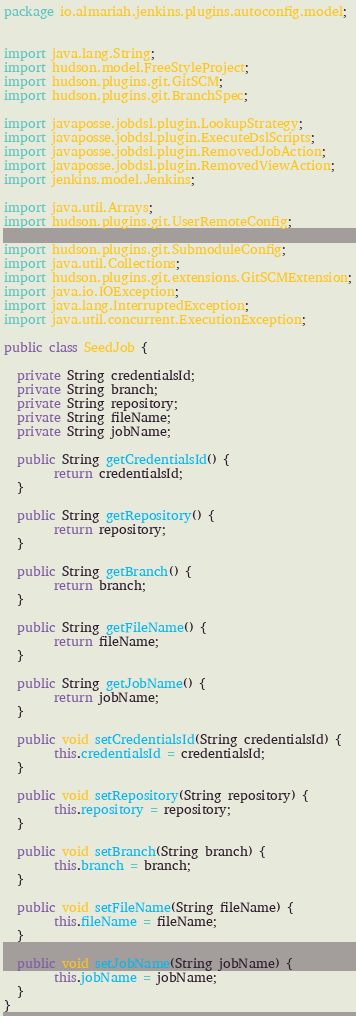Convert code to text. <code><loc_0><loc_0><loc_500><loc_500><_Java_>package io.almariah.jenkins.plugins.autoconfig.model;


import java.lang.String;
import hudson.model.FreeStyleProject;
import hudson.plugins.git.GitSCM;
import hudson.plugins.git.BranchSpec;

import javaposse.jobdsl.plugin.LookupStrategy;
import javaposse.jobdsl.plugin.ExecuteDslScripts;
import javaposse.jobdsl.plugin.RemovedJobAction;
import javaposse.jobdsl.plugin.RemovedViewAction;
import jenkins.model.Jenkins;

import java.util.Arrays;
import hudson.plugins.git.UserRemoteConfig;

import hudson.plugins.git.SubmoduleConfig;
import java.util.Collections;
import hudson.plugins.git.extensions.GitSCMExtension;
import java.io.IOException;
import java.lang.InterruptedException;
import java.util.concurrent.ExecutionException;

public class SeedJob {
  
  private String credentialsId;
  private String branch;
  private String repository;
  private String fileName;
  private String jobName;

  public String getCredentialsId() {
        return credentialsId;
  }

  public String getRepository() {
        return repository;
  }

  public String getBranch() {
        return branch;
  }

  public String getFileName() {
        return fileName;
  }

  public String getJobName() {
        return jobName;
  }

  public void setCredentialsId(String credentialsId) {
        this.credentialsId = credentialsId;
  }

  public void setRepository(String repository) {
        this.repository = repository;
  }

  public void setBranch(String branch) {
        this.branch = branch;
  }

  public void setFileName(String fileName) {
        this.fileName = fileName;
  }

  public void setJobName(String jobName) {
        this.jobName = jobName;
  }
}
</code> 